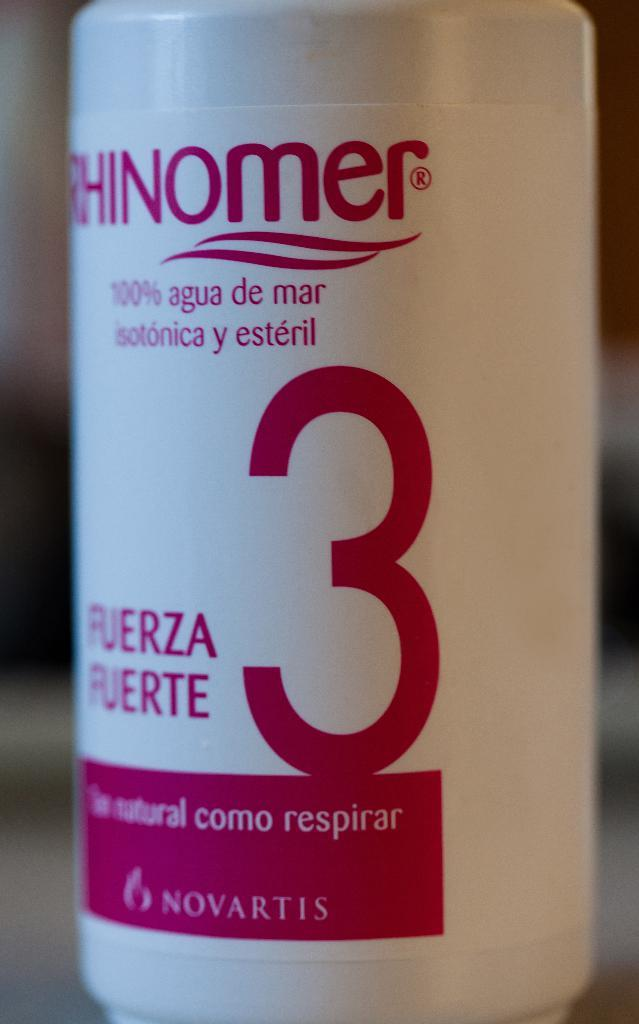Provide a one-sentence caption for the provided image. The bottle has a large number three on it written in red. 